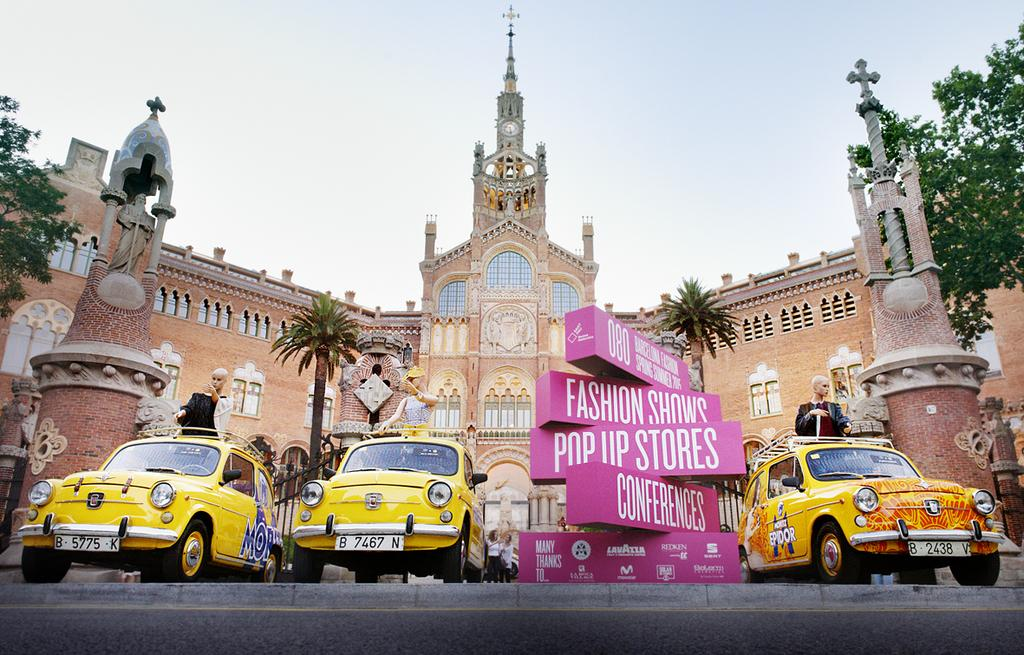<image>
Render a clear and concise summary of the photo. three yellow cars and some pink signs, one of which reads pop up stores. 